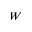Convert formula to latex. <formula><loc_0><loc_0><loc_500><loc_500>W</formula> 